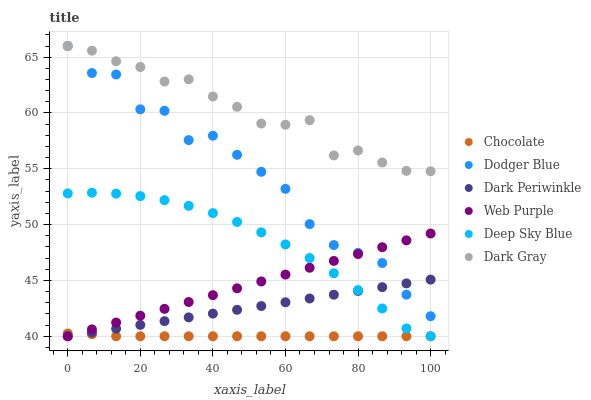Does Chocolate have the minimum area under the curve?
Answer yes or no. Yes. Does Dark Gray have the maximum area under the curve?
Answer yes or no. Yes. Does Web Purple have the minimum area under the curve?
Answer yes or no. No. Does Web Purple have the maximum area under the curve?
Answer yes or no. No. Is Web Purple the smoothest?
Answer yes or no. Yes. Is Dodger Blue the roughest?
Answer yes or no. Yes. Is Dark Gray the smoothest?
Answer yes or no. No. Is Dark Gray the roughest?
Answer yes or no. No. Does Chocolate have the lowest value?
Answer yes or no. Yes. Does Dark Gray have the lowest value?
Answer yes or no. No. Does Dodger Blue have the highest value?
Answer yes or no. Yes. Does Web Purple have the highest value?
Answer yes or no. No. Is Dark Periwinkle less than Dark Gray?
Answer yes or no. Yes. Is Dark Gray greater than Web Purple?
Answer yes or no. Yes. Does Dark Periwinkle intersect Chocolate?
Answer yes or no. Yes. Is Dark Periwinkle less than Chocolate?
Answer yes or no. No. Is Dark Periwinkle greater than Chocolate?
Answer yes or no. No. Does Dark Periwinkle intersect Dark Gray?
Answer yes or no. No. 